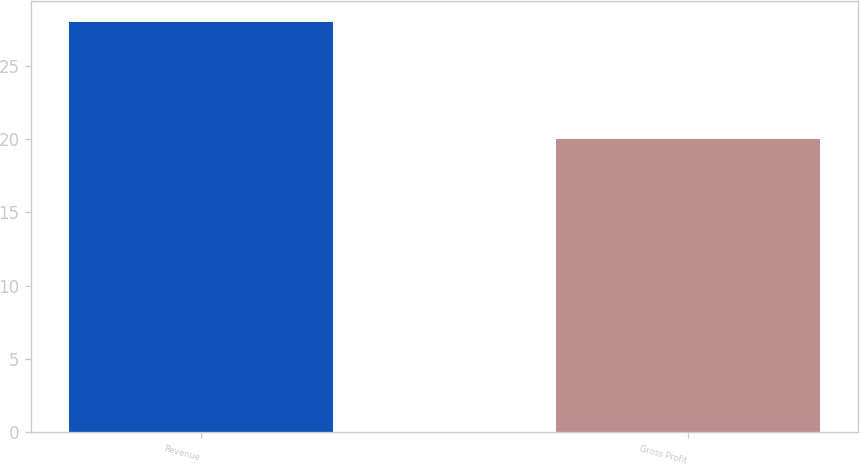Convert chart. <chart><loc_0><loc_0><loc_500><loc_500><bar_chart><fcel>Revenue<fcel>Gross Profit<nl><fcel>28<fcel>20<nl></chart> 